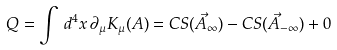Convert formula to latex. <formula><loc_0><loc_0><loc_500><loc_500>Q = \int \, d ^ { 4 } x \, \partial _ { \mu } K _ { \mu } ( A ) = C S ( \vec { A } _ { \infty } ) - C S ( \vec { A } _ { - \infty } ) + 0</formula> 